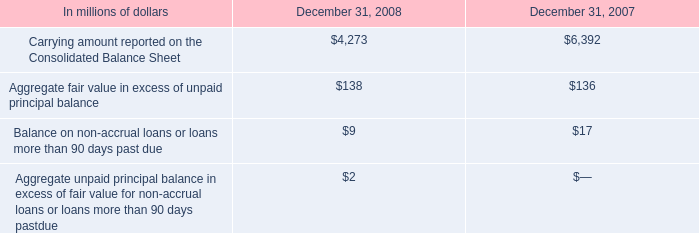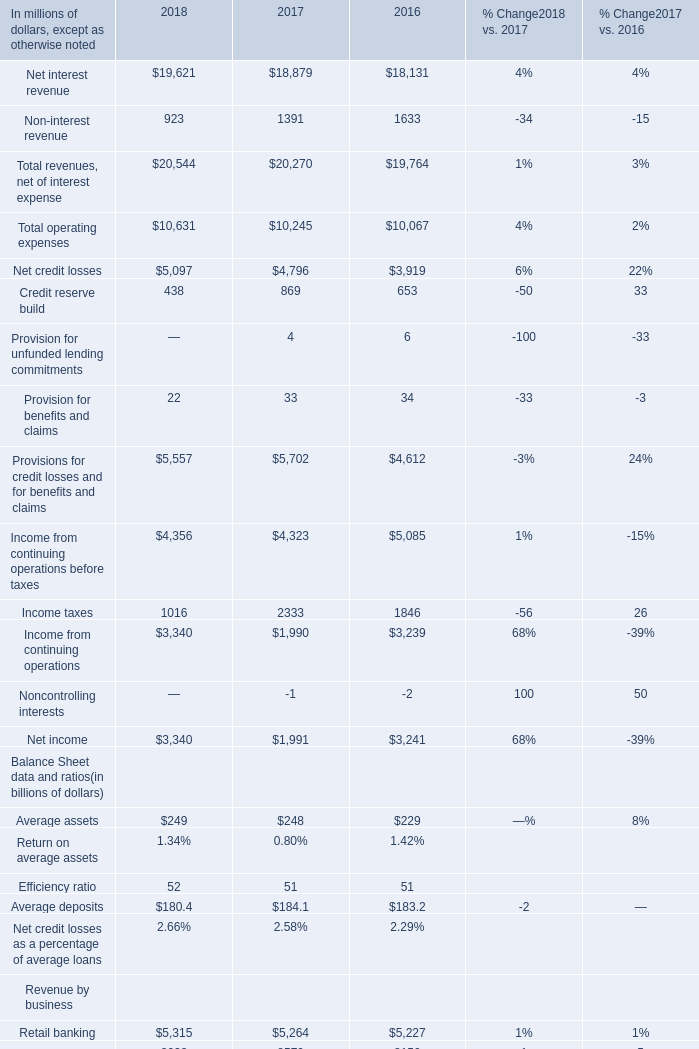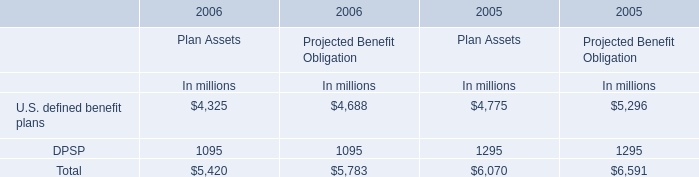If Retail banking develops with the same growth rate in 2018, what will it reach in 2019 (in million) 
Computations: ((1 + ((5315 - 5264) / 5264)) * 5315)
Answer: 5366.49411. 